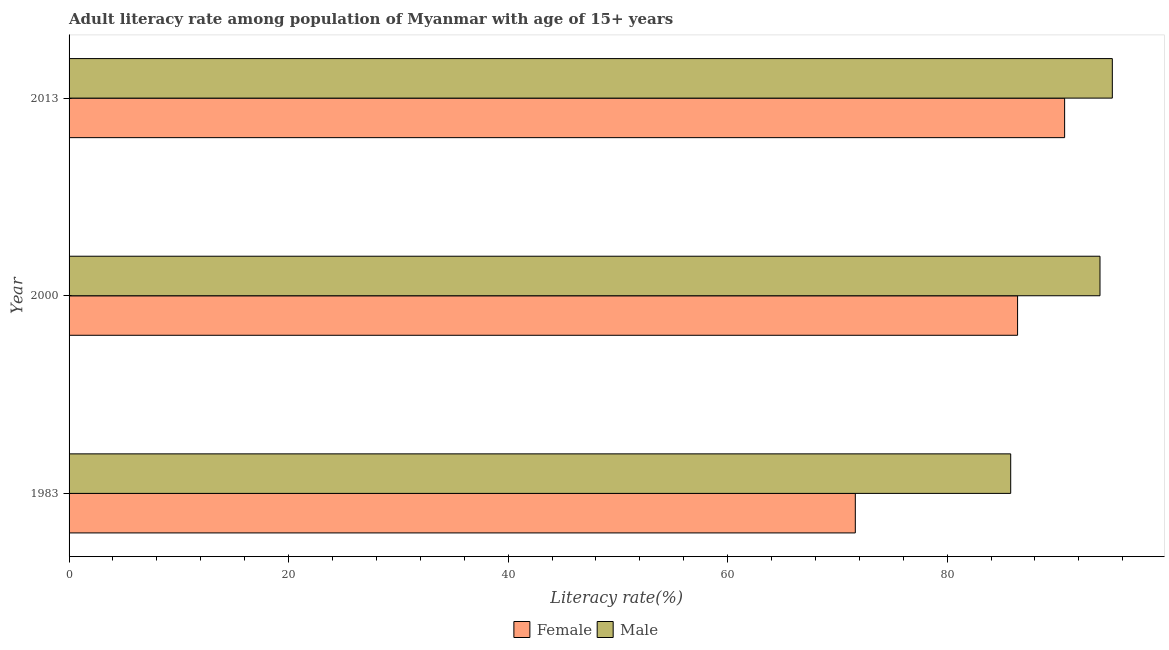How many different coloured bars are there?
Your answer should be very brief. 2. Are the number of bars per tick equal to the number of legend labels?
Ensure brevity in your answer.  Yes. Are the number of bars on each tick of the Y-axis equal?
Provide a short and direct response. Yes. How many bars are there on the 3rd tick from the bottom?
Give a very brief answer. 2. What is the label of the 1st group of bars from the top?
Provide a succinct answer. 2013. In how many cases, is the number of bars for a given year not equal to the number of legend labels?
Keep it short and to the point. 0. What is the male adult literacy rate in 1983?
Offer a very short reply. 85.79. Across all years, what is the maximum female adult literacy rate?
Make the answer very short. 90.7. Across all years, what is the minimum female adult literacy rate?
Your response must be concise. 71.63. In which year was the female adult literacy rate maximum?
Provide a short and direct response. 2013. In which year was the male adult literacy rate minimum?
Your answer should be very brief. 1983. What is the total male adult literacy rate in the graph?
Keep it short and to the point. 274.76. What is the difference between the female adult literacy rate in 2000 and that in 2013?
Ensure brevity in your answer.  -4.29. What is the difference between the female adult literacy rate in 2000 and the male adult literacy rate in 1983?
Ensure brevity in your answer.  0.63. What is the average female adult literacy rate per year?
Give a very brief answer. 82.92. In the year 1983, what is the difference between the male adult literacy rate and female adult literacy rate?
Provide a succinct answer. 14.16. Is the female adult literacy rate in 1983 less than that in 2013?
Offer a terse response. Yes. Is the difference between the male adult literacy rate in 1983 and 2013 greater than the difference between the female adult literacy rate in 1983 and 2013?
Provide a short and direct response. Yes. What is the difference between the highest and the second highest female adult literacy rate?
Your answer should be compact. 4.29. What is the difference between the highest and the lowest female adult literacy rate?
Offer a terse response. 19.07. Is the sum of the female adult literacy rate in 2000 and 2013 greater than the maximum male adult literacy rate across all years?
Provide a short and direct response. Yes. What does the 2nd bar from the top in 2000 represents?
Your response must be concise. Female. What does the 1st bar from the bottom in 2013 represents?
Your answer should be very brief. Female. Are all the bars in the graph horizontal?
Give a very brief answer. Yes. What is the difference between two consecutive major ticks on the X-axis?
Offer a very short reply. 20. Does the graph contain any zero values?
Offer a very short reply. No. How are the legend labels stacked?
Offer a very short reply. Horizontal. What is the title of the graph?
Provide a short and direct response. Adult literacy rate among population of Myanmar with age of 15+ years. What is the label or title of the X-axis?
Your answer should be very brief. Literacy rate(%). What is the label or title of the Y-axis?
Ensure brevity in your answer.  Year. What is the Literacy rate(%) in Female in 1983?
Your answer should be compact. 71.63. What is the Literacy rate(%) of Male in 1983?
Make the answer very short. 85.79. What is the Literacy rate(%) in Female in 2000?
Make the answer very short. 86.42. What is the Literacy rate(%) of Male in 2000?
Your answer should be compact. 93.92. What is the Literacy rate(%) of Female in 2013?
Your answer should be very brief. 90.7. What is the Literacy rate(%) in Male in 2013?
Give a very brief answer. 95.05. Across all years, what is the maximum Literacy rate(%) of Female?
Provide a short and direct response. 90.7. Across all years, what is the maximum Literacy rate(%) in Male?
Your response must be concise. 95.05. Across all years, what is the minimum Literacy rate(%) in Female?
Your answer should be compact. 71.63. Across all years, what is the minimum Literacy rate(%) in Male?
Provide a short and direct response. 85.79. What is the total Literacy rate(%) in Female in the graph?
Offer a very short reply. 248.75. What is the total Literacy rate(%) of Male in the graph?
Your response must be concise. 274.76. What is the difference between the Literacy rate(%) of Female in 1983 and that in 2000?
Provide a succinct answer. -14.78. What is the difference between the Literacy rate(%) in Male in 1983 and that in 2000?
Offer a terse response. -8.14. What is the difference between the Literacy rate(%) in Female in 1983 and that in 2013?
Your answer should be very brief. -19.07. What is the difference between the Literacy rate(%) of Male in 1983 and that in 2013?
Ensure brevity in your answer.  -9.26. What is the difference between the Literacy rate(%) in Female in 2000 and that in 2013?
Keep it short and to the point. -4.29. What is the difference between the Literacy rate(%) of Male in 2000 and that in 2013?
Keep it short and to the point. -1.12. What is the difference between the Literacy rate(%) of Female in 1983 and the Literacy rate(%) of Male in 2000?
Ensure brevity in your answer.  -22.29. What is the difference between the Literacy rate(%) of Female in 1983 and the Literacy rate(%) of Male in 2013?
Give a very brief answer. -23.42. What is the difference between the Literacy rate(%) of Female in 2000 and the Literacy rate(%) of Male in 2013?
Offer a terse response. -8.63. What is the average Literacy rate(%) of Female per year?
Your response must be concise. 82.92. What is the average Literacy rate(%) of Male per year?
Your answer should be compact. 91.59. In the year 1983, what is the difference between the Literacy rate(%) of Female and Literacy rate(%) of Male?
Offer a terse response. -14.16. In the year 2000, what is the difference between the Literacy rate(%) of Female and Literacy rate(%) of Male?
Your answer should be compact. -7.51. In the year 2013, what is the difference between the Literacy rate(%) of Female and Literacy rate(%) of Male?
Your answer should be compact. -4.35. What is the ratio of the Literacy rate(%) of Female in 1983 to that in 2000?
Your answer should be very brief. 0.83. What is the ratio of the Literacy rate(%) of Male in 1983 to that in 2000?
Keep it short and to the point. 0.91. What is the ratio of the Literacy rate(%) of Female in 1983 to that in 2013?
Your answer should be very brief. 0.79. What is the ratio of the Literacy rate(%) of Male in 1983 to that in 2013?
Provide a short and direct response. 0.9. What is the ratio of the Literacy rate(%) of Female in 2000 to that in 2013?
Ensure brevity in your answer.  0.95. What is the difference between the highest and the second highest Literacy rate(%) of Female?
Your response must be concise. 4.29. What is the difference between the highest and the second highest Literacy rate(%) in Male?
Your response must be concise. 1.12. What is the difference between the highest and the lowest Literacy rate(%) of Female?
Provide a succinct answer. 19.07. What is the difference between the highest and the lowest Literacy rate(%) in Male?
Offer a terse response. 9.26. 